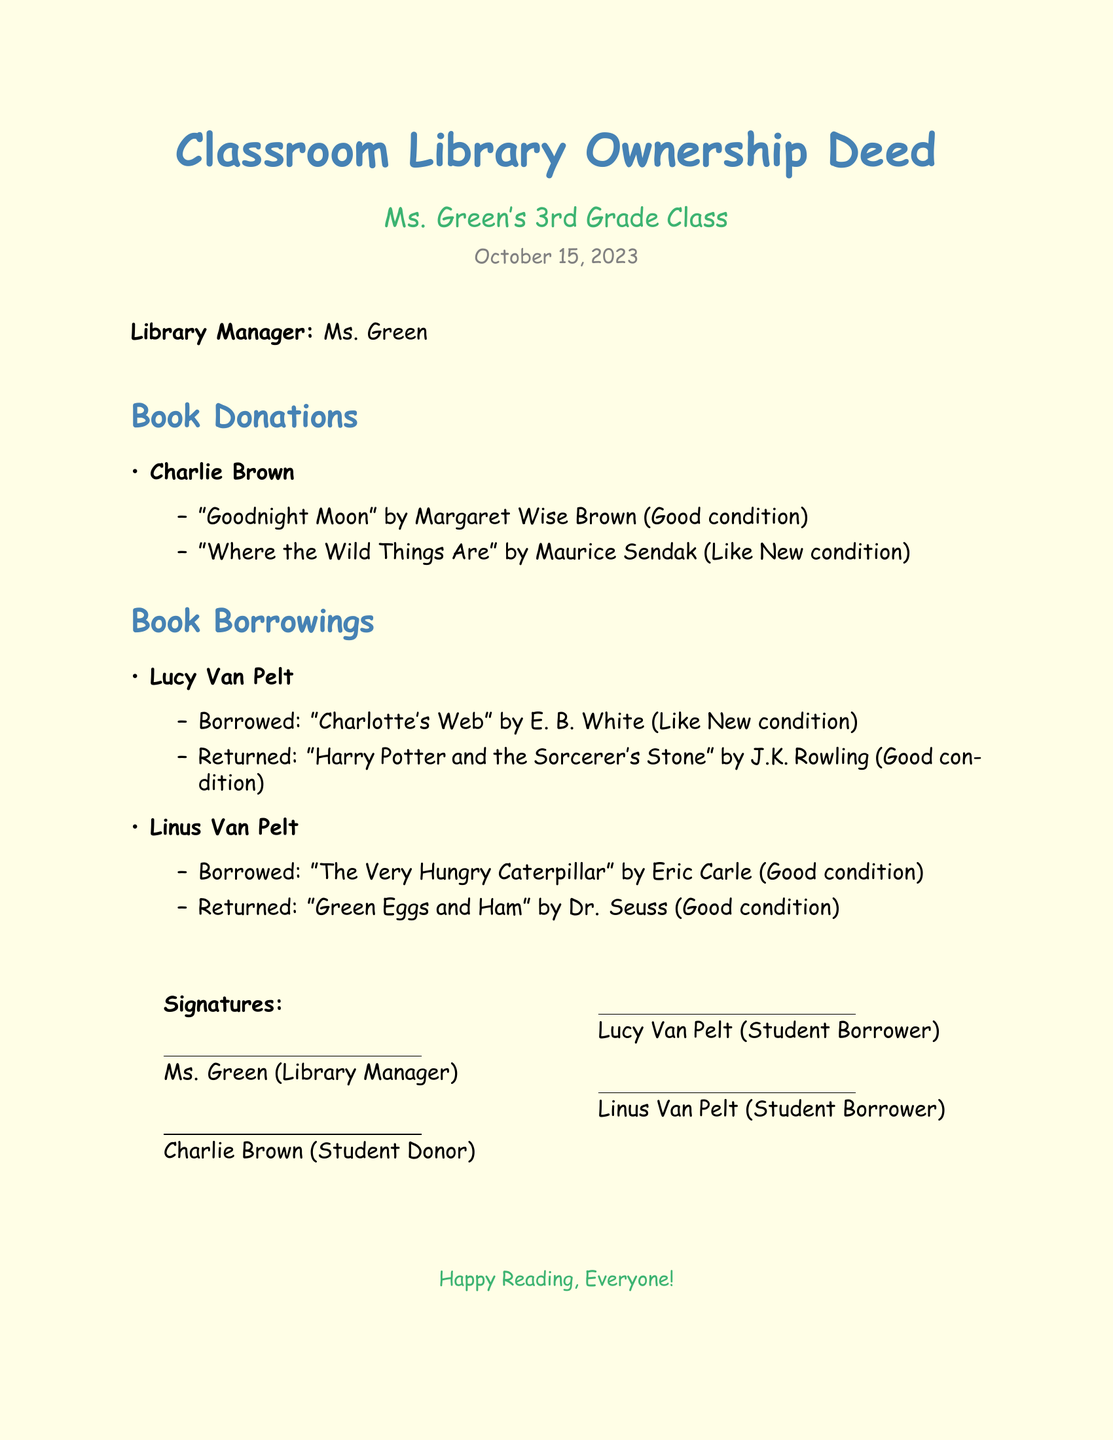What is the title of the document? The title of the document is displayed prominently at the beginning and refers to the ownership of the classroom library.
Answer: Classroom Library Ownership Deed Who is the Library Manager? The Library Manager's name is listed in the document as the responsible person for the library.
Answer: Ms. Green When was the deed signed? The document includes a date to indicate when it was created or signed.
Answer: October 15, 2023 How many books did Charlie Brown donate? The document lists the books donated by Charlie Brown, which can be counted for the answer.
Answer: 2 What book did Lucy Van Pelt borrow? The document specifies which book was borrowed by Lucy Van Pelt.
Answer: Charlotte's Web In what condition was "Harry Potter and the Sorcerer's Stone" returned? The returned book's condition is noted in the list of borrowings and returns.
Answer: Good condition Who donated the books listed in the document? The document shows who is responsible for the donations made to the classroom library.
Answer: Charlie Brown How many students borrowed books in total? By checking the borrowings section, we can determine the number of distinct borrowers.
Answer: 2 What is the condition of "The Very Hungry Caterpillar"? The document indicates the status of the book borrowed by Linus Van Pelt.
Answer: Good condition 